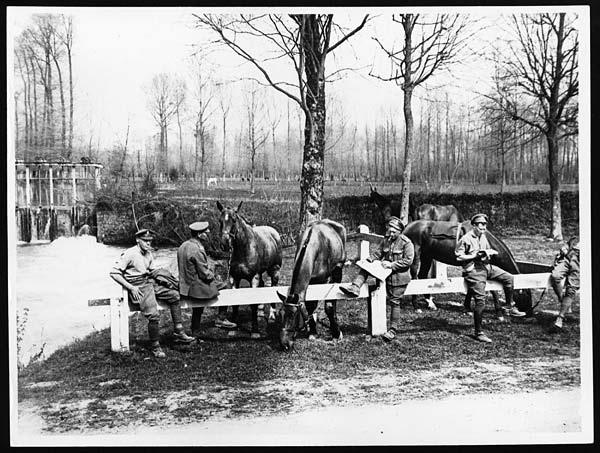What style of photo is this?
Quick response, please. Black and white. What is the person next to the horse holding?
Quick response, please. Book. How many people are pictured?
Concise answer only. 5. What kind of animals are in the picture?
Short answer required. Horses. 